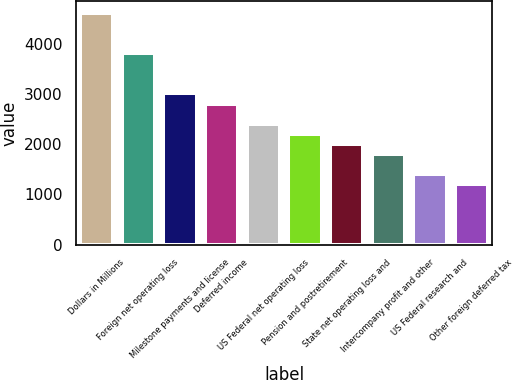Convert chart to OTSL. <chart><loc_0><loc_0><loc_500><loc_500><bar_chart><fcel>Dollars in Millions<fcel>Foreign net operating loss<fcel>Milestone payments and license<fcel>Deferred income<fcel>US Federal net operating loss<fcel>Pension and postretirement<fcel>State net operating loss and<fcel>Intercompany profit and other<fcel>US Federal research and<fcel>Other foreign deferred tax<nl><fcel>4616.5<fcel>3814.5<fcel>3012.5<fcel>2812<fcel>2411<fcel>2210.5<fcel>2010<fcel>1809.5<fcel>1408.5<fcel>1208<nl></chart> 